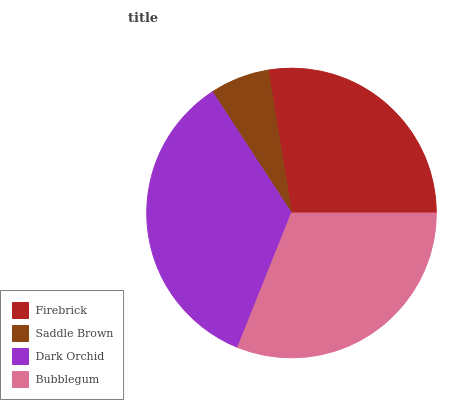Is Saddle Brown the minimum?
Answer yes or no. Yes. Is Dark Orchid the maximum?
Answer yes or no. Yes. Is Dark Orchid the minimum?
Answer yes or no. No. Is Saddle Brown the maximum?
Answer yes or no. No. Is Dark Orchid greater than Saddle Brown?
Answer yes or no. Yes. Is Saddle Brown less than Dark Orchid?
Answer yes or no. Yes. Is Saddle Brown greater than Dark Orchid?
Answer yes or no. No. Is Dark Orchid less than Saddle Brown?
Answer yes or no. No. Is Bubblegum the high median?
Answer yes or no. Yes. Is Firebrick the low median?
Answer yes or no. Yes. Is Saddle Brown the high median?
Answer yes or no. No. Is Dark Orchid the low median?
Answer yes or no. No. 